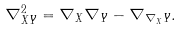Convert formula to latex. <formula><loc_0><loc_0><loc_500><loc_500>\nabla ^ { 2 } _ { X Y } = \nabla _ { X } \nabla _ { Y } - \nabla _ { \nabla _ { X } Y } .</formula> 